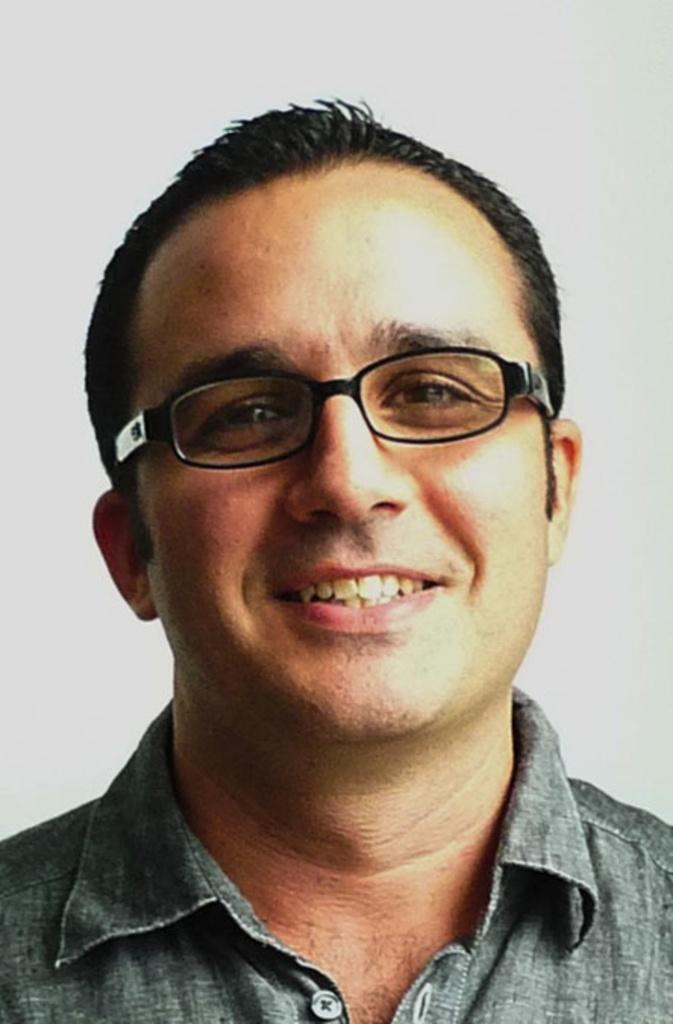What is the main subject of the image? The main subject of the image is a man. What is the man's facial expression in the image? The man is smiling in the image. What color is the background of the image? The background of the image is white. What is the man's purpose for being in the image during the afternoon? The image does not provide information about the time of day or the man's purpose for being in the image. 